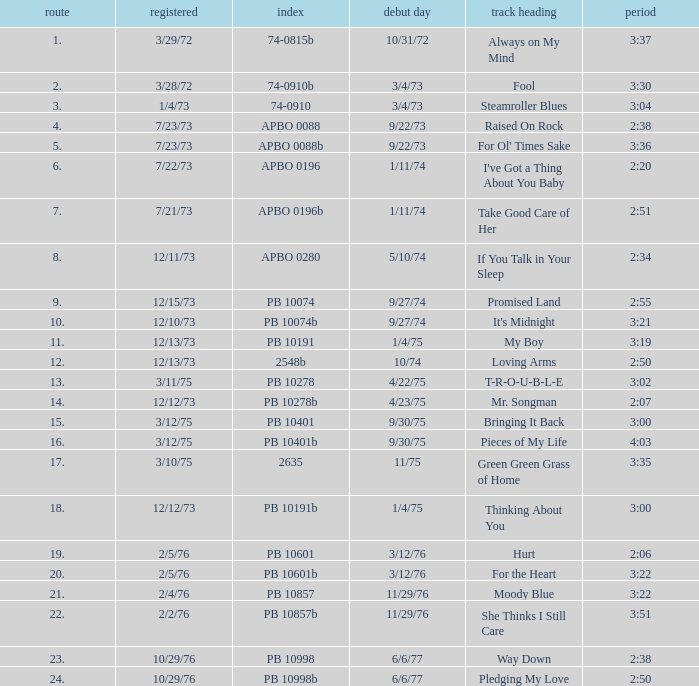Tell me the time for 6/6/77 release date and song title of way down 2:38. 